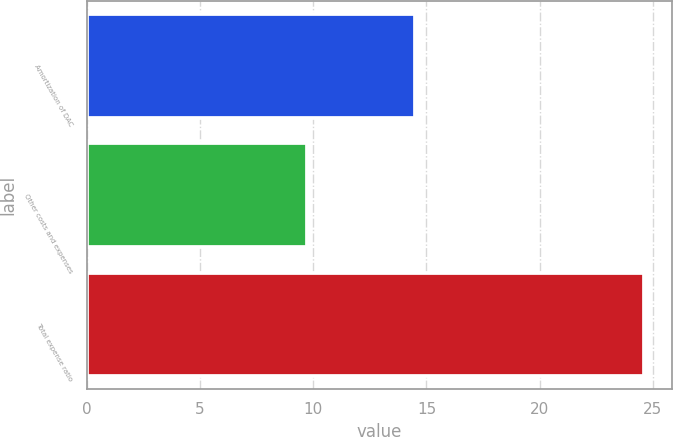Convert chart to OTSL. <chart><loc_0><loc_0><loc_500><loc_500><bar_chart><fcel>Amortization of DAC<fcel>Other costs and expenses<fcel>Total expense ratio<nl><fcel>14.5<fcel>9.7<fcel>24.6<nl></chart> 